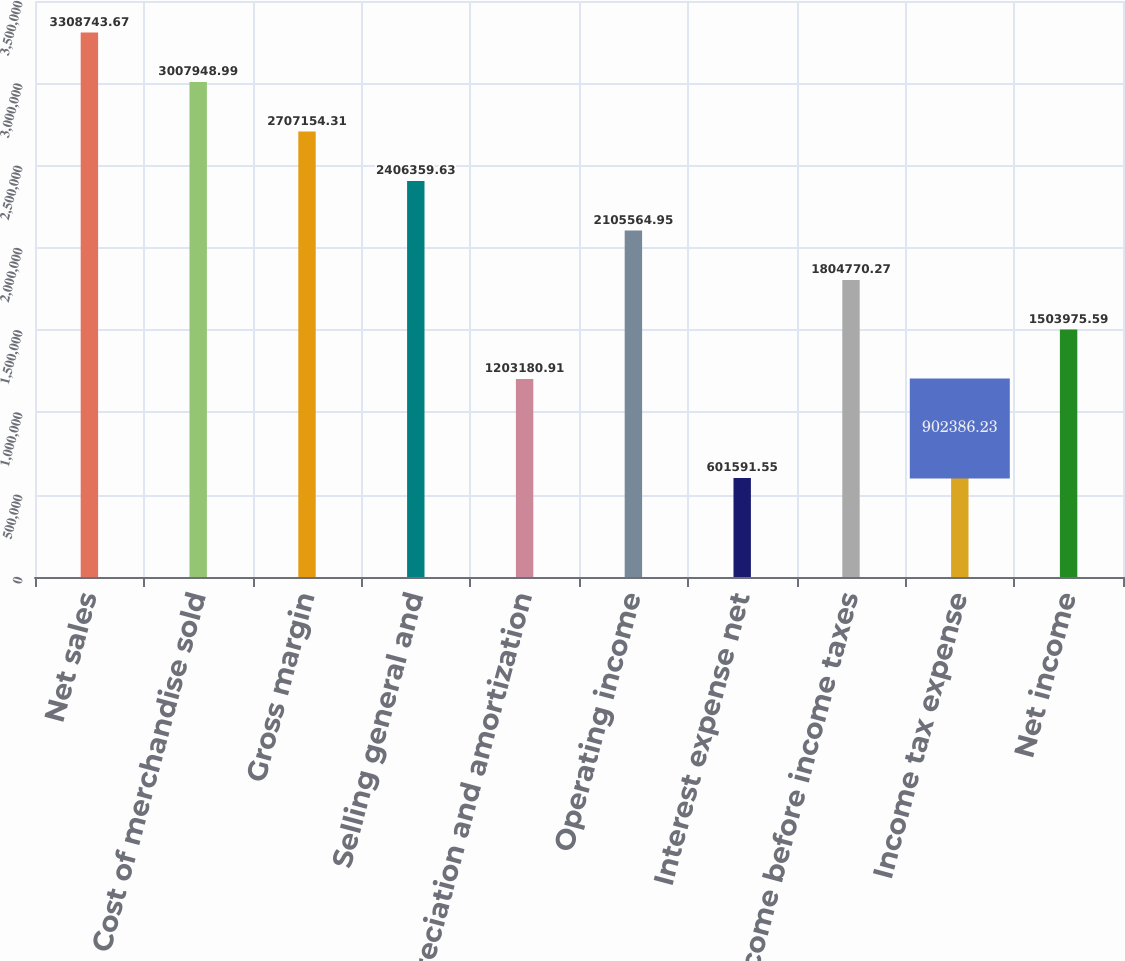Convert chart. <chart><loc_0><loc_0><loc_500><loc_500><bar_chart><fcel>Net sales<fcel>Cost of merchandise sold<fcel>Gross margin<fcel>Selling general and<fcel>Depreciation and amortization<fcel>Operating income<fcel>Interest expense net<fcel>Income before income taxes<fcel>Income tax expense<fcel>Net income<nl><fcel>3.30874e+06<fcel>3.00795e+06<fcel>2.70715e+06<fcel>2.40636e+06<fcel>1.20318e+06<fcel>2.10556e+06<fcel>601592<fcel>1.80477e+06<fcel>902386<fcel>1.50398e+06<nl></chart> 